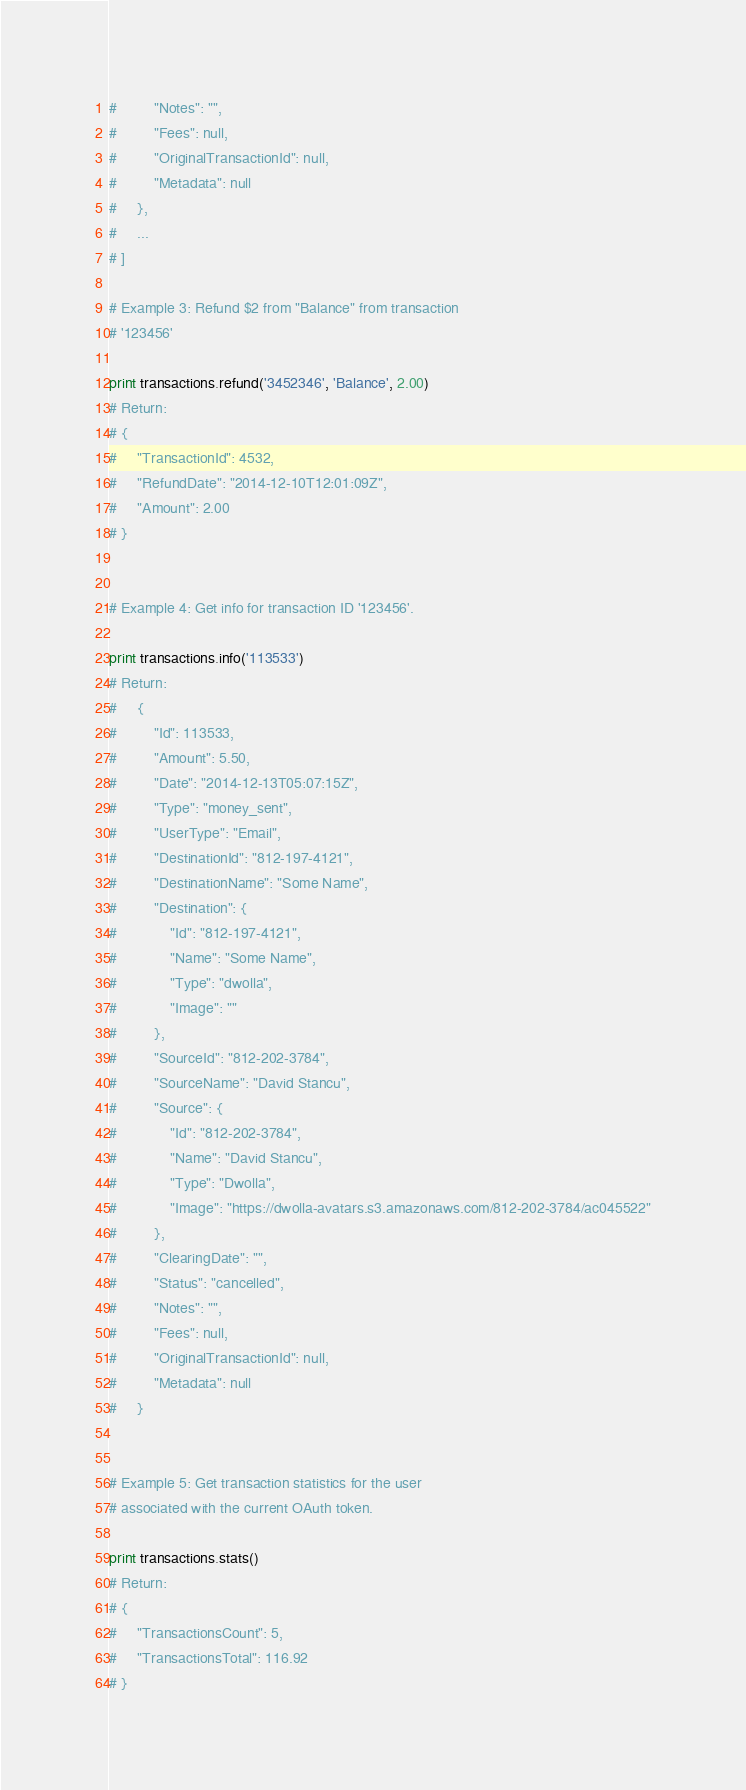Convert code to text. <code><loc_0><loc_0><loc_500><loc_500><_Python_>#         "Notes": "",
#         "Fees": null,
#         "OriginalTransactionId": null,
#         "Metadata": null
#     },
#     ...
# ]

# Example 3: Refund $2 from "Balance" from transaction
# '123456'

print transactions.refund('3452346', 'Balance', 2.00)
# Return:
# {
#     "TransactionId": 4532,
#     "RefundDate": "2014-12-10T12:01:09Z",
#     "Amount": 2.00
# }


# Example 4: Get info for transaction ID '123456'.

print transactions.info('113533')
# Return:
#     {
#         "Id": 113533,
#         "Amount": 5.50,
#         "Date": "2014-12-13T05:07:15Z",
#         "Type": "money_sent",
#         "UserType": "Email",
#         "DestinationId": "812-197-4121",
#         "DestinationName": "Some Name",
#         "Destination": {
#             "Id": "812-197-4121",
#             "Name": "Some Name",
#             "Type": "dwolla",
#             "Image": ""
#         },
#         "SourceId": "812-202-3784",
#         "SourceName": "David Stancu",
#         "Source": {
#             "Id": "812-202-3784",
#             "Name": "David Stancu",
#             "Type": "Dwolla",
#             "Image": "https://dwolla-avatars.s3.amazonaws.com/812-202-3784/ac045522"
#         },
#         "ClearingDate": "",
#         "Status": "cancelled",
#         "Notes": "",
#         "Fees": null,
#         "OriginalTransactionId": null,
#         "Metadata": null
#     }


# Example 5: Get transaction statistics for the user
# associated with the current OAuth token.

print transactions.stats()
# Return:
# {
#     "TransactionsCount": 5,
#     "TransactionsTotal": 116.92
# }</code> 